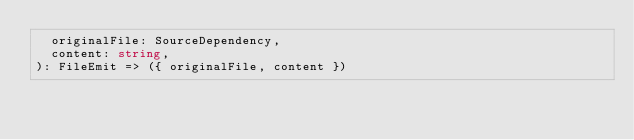<code> <loc_0><loc_0><loc_500><loc_500><_TypeScript_>  originalFile: SourceDependency,
  content: string,
): FileEmit => ({ originalFile, content })
</code> 